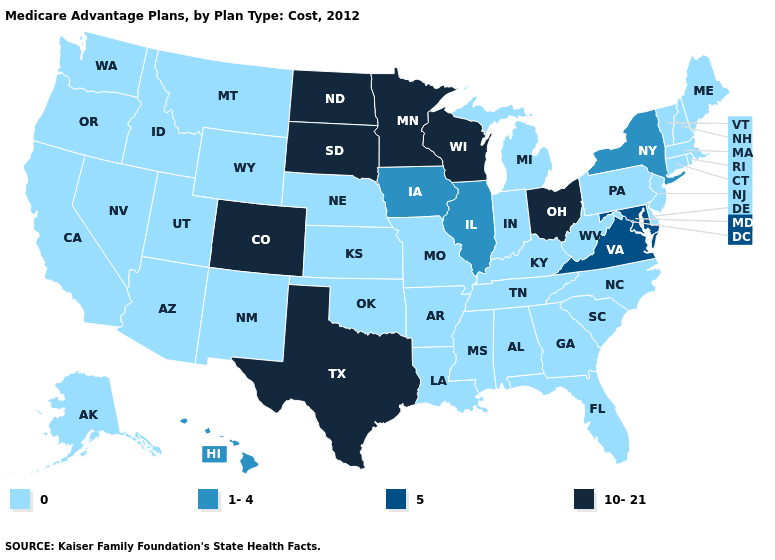What is the lowest value in the South?
Short answer required. 0. What is the value of Virginia?
Be succinct. 5. What is the value of Iowa?
Short answer required. 1-4. Name the states that have a value in the range 0?
Answer briefly. Alaska, Alabama, Arkansas, Arizona, California, Connecticut, Delaware, Florida, Georgia, Idaho, Indiana, Kansas, Kentucky, Louisiana, Massachusetts, Maine, Michigan, Missouri, Mississippi, Montana, North Carolina, Nebraska, New Hampshire, New Jersey, New Mexico, Nevada, Oklahoma, Oregon, Pennsylvania, Rhode Island, South Carolina, Tennessee, Utah, Vermont, Washington, West Virginia, Wyoming. How many symbols are there in the legend?
Keep it brief. 4. Does the first symbol in the legend represent the smallest category?
Be succinct. Yes. What is the value of Florida?
Keep it brief. 0. What is the value of Connecticut?
Quick response, please. 0. Name the states that have a value in the range 5?
Give a very brief answer. Maryland, Virginia. Does Nevada have the lowest value in the USA?
Answer briefly. Yes. What is the value of New York?
Concise answer only. 1-4. Does Tennessee have a lower value than Kansas?
Concise answer only. No. Does North Carolina have the same value as Iowa?
Quick response, please. No. Name the states that have a value in the range 5?
Answer briefly. Maryland, Virginia. Does the first symbol in the legend represent the smallest category?
Give a very brief answer. Yes. 